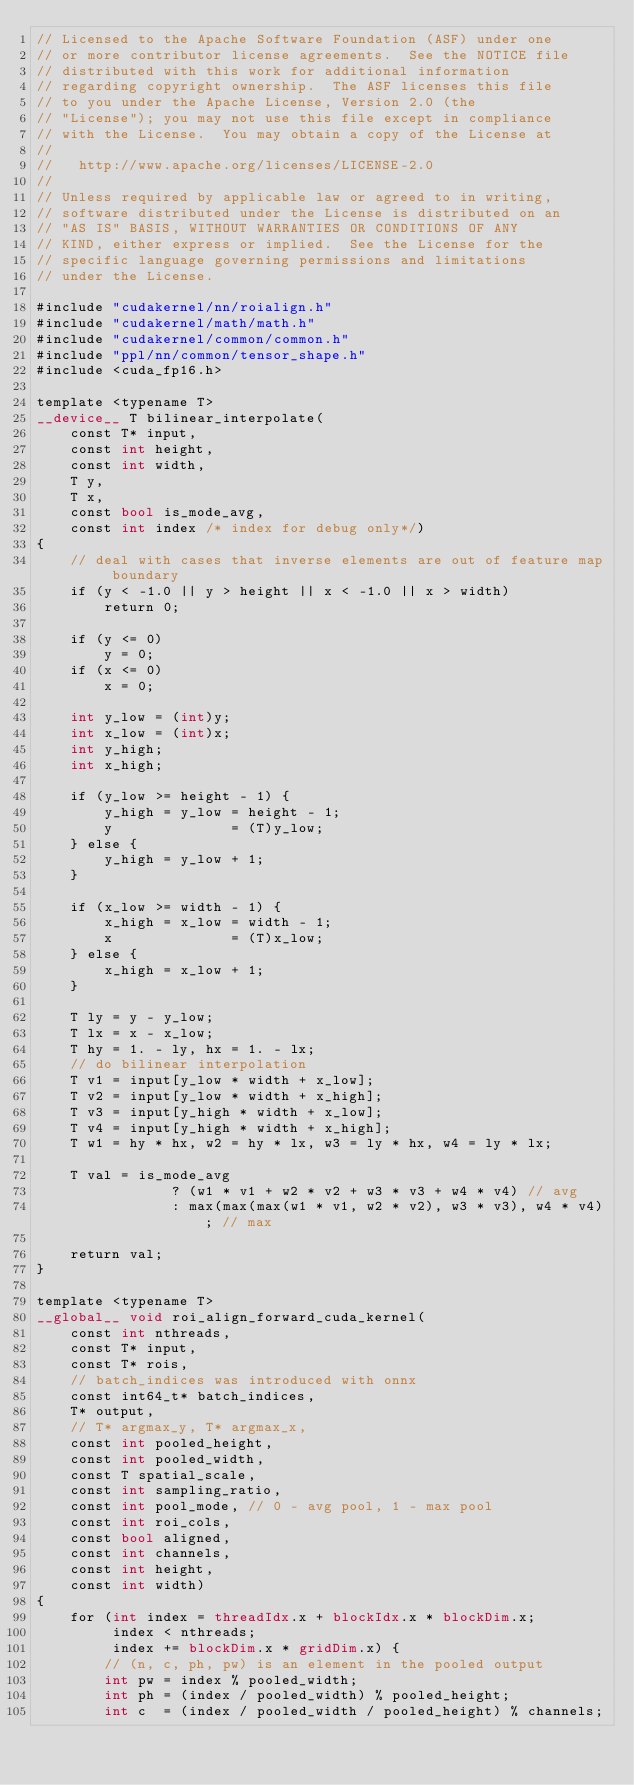Convert code to text. <code><loc_0><loc_0><loc_500><loc_500><_Cuda_>// Licensed to the Apache Software Foundation (ASF) under one
// or more contributor license agreements.  See the NOTICE file
// distributed with this work for additional information
// regarding copyright ownership.  The ASF licenses this file
// to you under the Apache License, Version 2.0 (the
// "License"); you may not use this file except in compliance
// with the License.  You may obtain a copy of the License at
//
//   http://www.apache.org/licenses/LICENSE-2.0
//
// Unless required by applicable law or agreed to in writing,
// software distributed under the License is distributed on an
// "AS IS" BASIS, WITHOUT WARRANTIES OR CONDITIONS OF ANY
// KIND, either express or implied.  See the License for the
// specific language governing permissions and limitations
// under the License.

#include "cudakernel/nn/roialign.h"
#include "cudakernel/math/math.h"
#include "cudakernel/common/common.h"
#include "ppl/nn/common/tensor_shape.h"
#include <cuda_fp16.h>

template <typename T>
__device__ T bilinear_interpolate(
    const T* input,
    const int height,
    const int width,
    T y,
    T x,
    const bool is_mode_avg,
    const int index /* index for debug only*/)
{
    // deal with cases that inverse elements are out of feature map boundary
    if (y < -1.0 || y > height || x < -1.0 || x > width)
        return 0;

    if (y <= 0)
        y = 0;
    if (x <= 0)
        x = 0;

    int y_low = (int)y;
    int x_low = (int)x;
    int y_high;
    int x_high;

    if (y_low >= height - 1) {
        y_high = y_low = height - 1;
        y              = (T)y_low;
    } else {
        y_high = y_low + 1;
    }

    if (x_low >= width - 1) {
        x_high = x_low = width - 1;
        x              = (T)x_low;
    } else {
        x_high = x_low + 1;
    }

    T ly = y - y_low;
    T lx = x - x_low;
    T hy = 1. - ly, hx = 1. - lx;
    // do bilinear interpolation
    T v1 = input[y_low * width + x_low];
    T v2 = input[y_low * width + x_high];
    T v3 = input[y_high * width + x_low];
    T v4 = input[y_high * width + x_high];
    T w1 = hy * hx, w2 = hy * lx, w3 = ly * hx, w4 = ly * lx;

    T val = is_mode_avg
                ? (w1 * v1 + w2 * v2 + w3 * v3 + w4 * v4) // avg
                : max(max(max(w1 * v1, w2 * v2), w3 * v3), w4 * v4); // max

    return val;
}

template <typename T>
__global__ void roi_align_forward_cuda_kernel(
    const int nthreads,
    const T* input,
    const T* rois,
    // batch_indices was introduced with onnx
    const int64_t* batch_indices,
    T* output,
    // T* argmax_y, T* argmax_x,
    const int pooled_height,
    const int pooled_width,
    const T spatial_scale,
    const int sampling_ratio,
    const int pool_mode, // 0 - avg pool, 1 - max pool
    const int roi_cols,
    const bool aligned,
    const int channels,
    const int height,
    const int width)
{
    for (int index = threadIdx.x + blockIdx.x * blockDim.x;
         index < nthreads;
         index += blockDim.x * gridDim.x) {
        // (n, c, ph, pw) is an element in the pooled output
        int pw = index % pooled_width;
        int ph = (index / pooled_width) % pooled_height;
        int c  = (index / pooled_width / pooled_height) % channels;</code> 